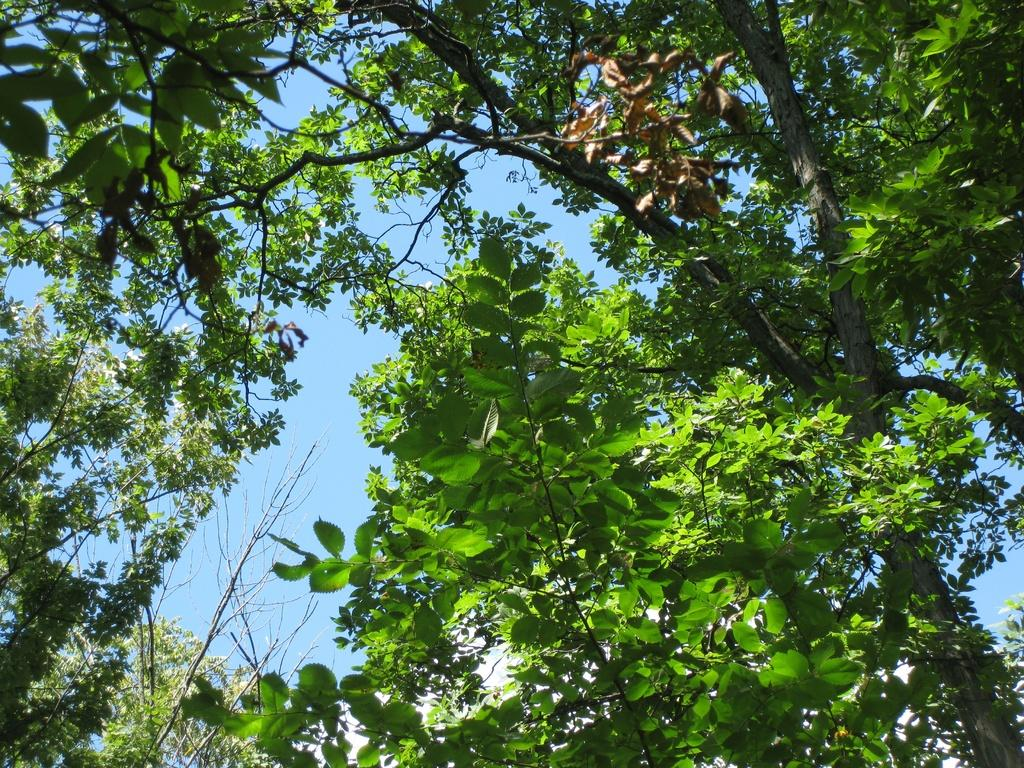What type of vegetation can be seen in the image? There is a plant and a tree in the image. What is visible in the background of the image? The sky is visible in the image. What is present on the ground in the image? There are dried leaves in the image. How many cars can be seen in the image? There are no cars present in the image. Are there any girls visible in the image? There are no girls present in the image. 